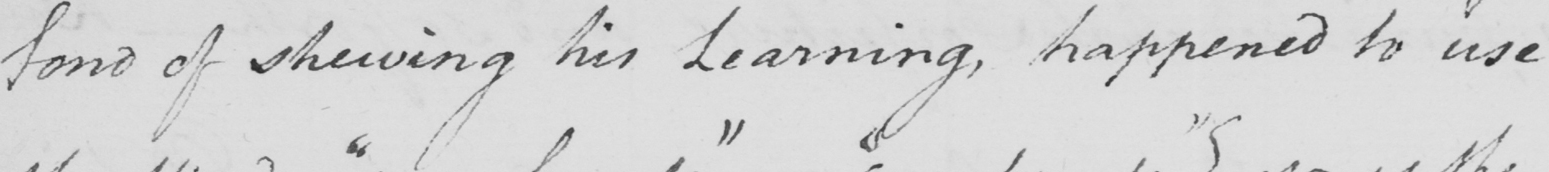What does this handwritten line say? fond of shewing his Learning , happened to use 